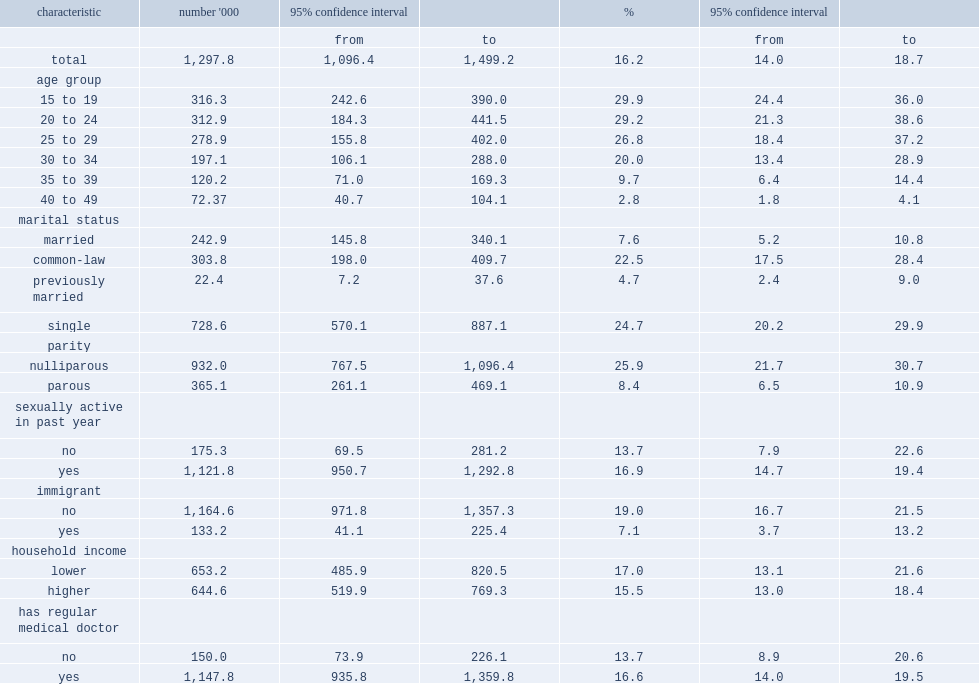According to combined data from the 2007 to 2009 and 2009 to 2011 chms, how many non-pregnant women aged 15 to 49 used ocs in the previous month? 1297.8. According to combined data from the 2007 to 2009 and 2009 to 2011 chms, what was the proportion of non-pregnant women aged 15 to 49 that used ocs in the previous month? 16.2. What was the prevalence of oc use among 15- to 19-year-olds? 29.9. What was the prevalence of oc use among 40- to 49-year-olds? 2.8. Was oc use higher among single women or was among married women? Single. Was oc use higher among single women or was that among previously married women? Single. Was oc use higher among nulliparous women or was that among parous women? Nulliparous. Was oc use higher among canadian-born (non-immigrant) women or was that among immigrant women? Immigrant no. 